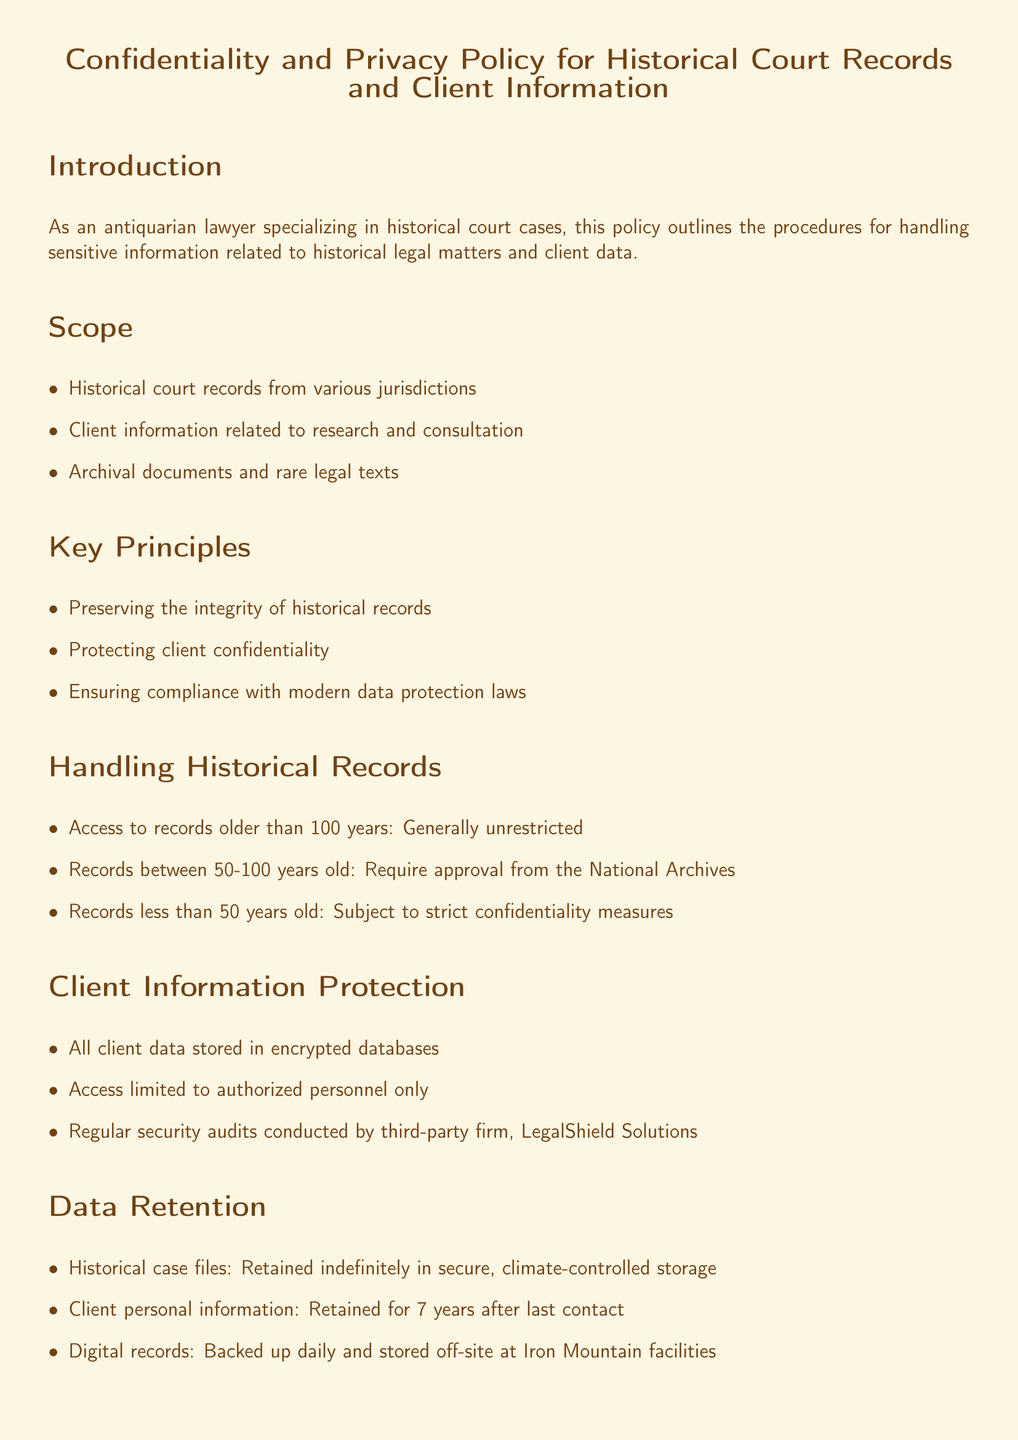What is the title of the policy document? The title is explicitly provided at the beginning of the document as "Confidentiality and Privacy Policy for Historical Court Records and Client Information."
Answer: Confidentiality and Privacy Policy for Historical Court Records and Client Information What is the age threshold for unrestricted access to historical records? The document specifies that records older than 100 years have generally unrestricted access.
Answer: 100 years Who is the Privacy Officer mentioned in the document? The Privacy Officer’s name and contact information are provided at the end of the document.
Answer: Jane Doe, Esq How long is client personal information retained after last contact? The document states that client personal information is retained for a specific duration after the final interaction.
Answer: 7 years What company conducts regular security audits as mentioned in the document? The document identifies a specific third-party firm responsible for conducting security audits.
Answer: LegalShield Solutions What is the protocol following a breach of confidentiality? The specific immediate action required by the organization in case of a breach is detailed in the Breach Protocol section.
Answer: Immediate notification to affected parties Which regulations does the document comply with? The compliance section lists specific regulations relevant to the handling of data and client information.
Answer: American Bar Association's Model Rules of Professional Conduct, EU General Data Protection Regulation (GDPR) What is done with digital records according to the data retention policy? The document provides information about the handling and storage of digital records.
Answer: Backed up daily and stored off-site at Iron Mountain facilities 